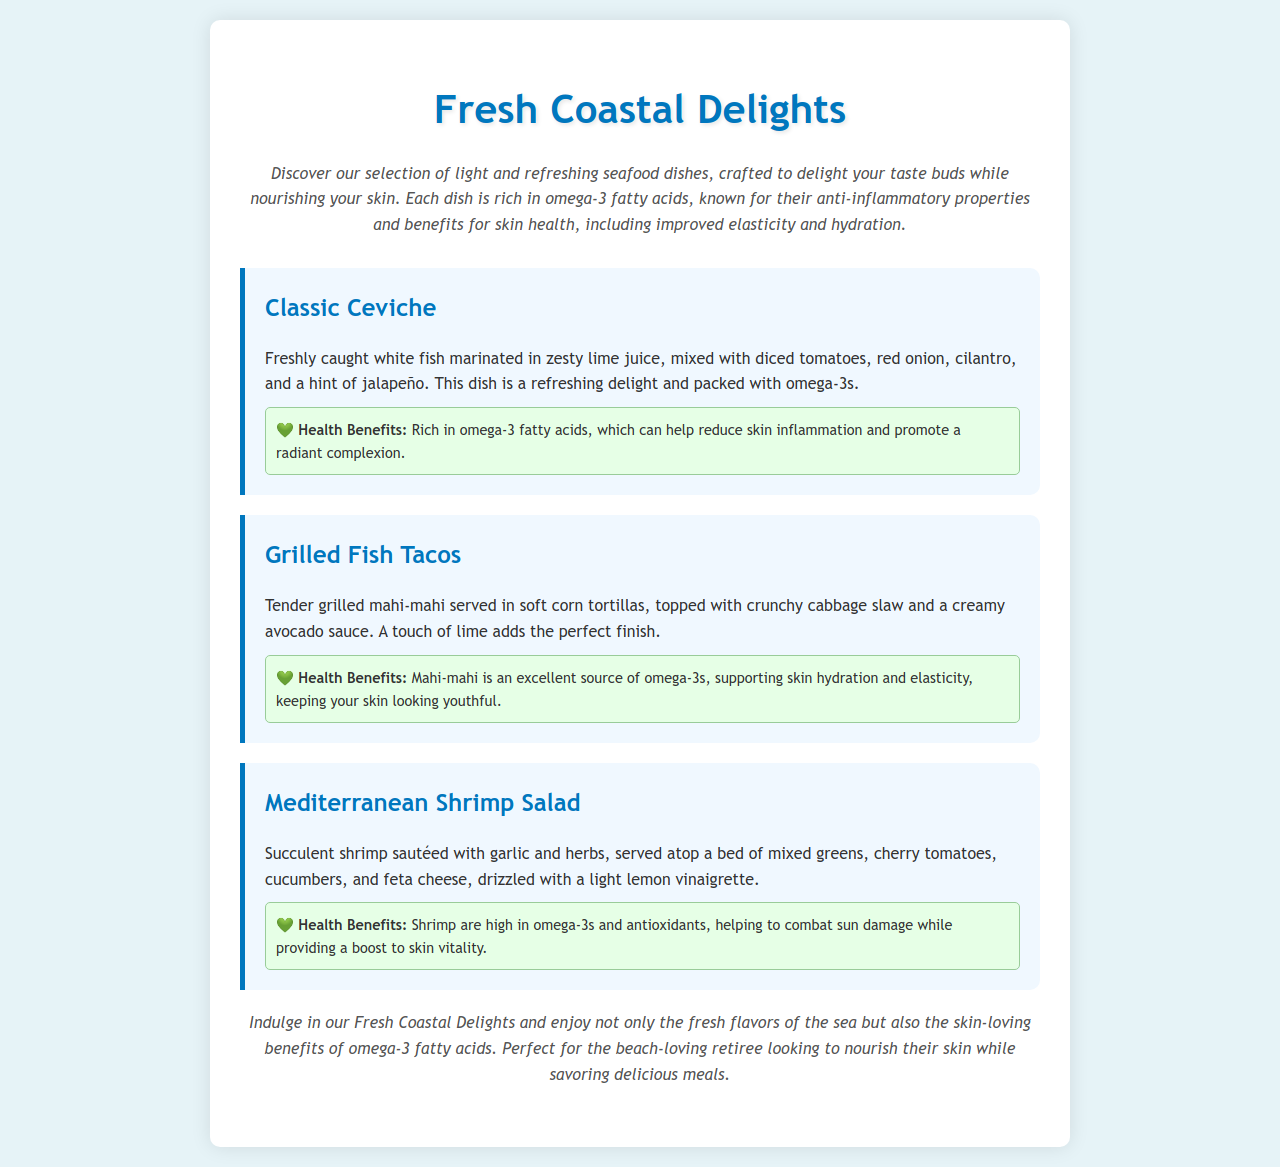what is the name of the first dish on the menu? The first dish listed in the menu is "Classic Ceviche."
Answer: Classic Ceviche how is the Classic Ceviche prepared? The preparation of Classic Ceviche includes marinating freshly caught white fish in lime juice and mixing it with tomatoes, red onion, cilantro, and jalapeño.
Answer: Marinated in lime juice with tomatoes, red onion, cilantro, and jalapeño what type of fish is used in the Grilled Fish Tacos? The dish uses "mahi-mahi," a type of fish.
Answer: mahi-mahi what is included in the Mediterranean Shrimp Salad? The Mediterranean Shrimp Salad includes shrimp, mixed greens, cherry tomatoes, cucumbers, and feta cheese, dressed with lemon vinaigrette.
Answer: Shrimp, mixed greens, cherry tomatoes, cucumbers, and feta cheese what is a health benefit of omega-3 fatty acids mentioned in the menu? The menu states that omega-3 fatty acids can help reduce skin inflammation and promote a radiant complexion.
Answer: Reduce skin inflammation and promote a radiant complexion how does the Grilled Fish Tacos support skin health? The menu notes that mahi-mahi is an excellent source of omega-3s, which supports skin hydration and elasticity.
Answer: Supports skin hydration and elasticity what is the main theme of the menu? The main theme is featuring light and refreshing seafood dishes rich in omega-3 fatty acids for skin health.
Answer: Light and refreshing seafood dishes rich in omega-3 fatty acids how does the menu cater to retirees? The menu highlights health benefits, appealing to retirees looking to nourish their skin while enjoying meals.
Answer: Nourish their skin while enjoying meals 